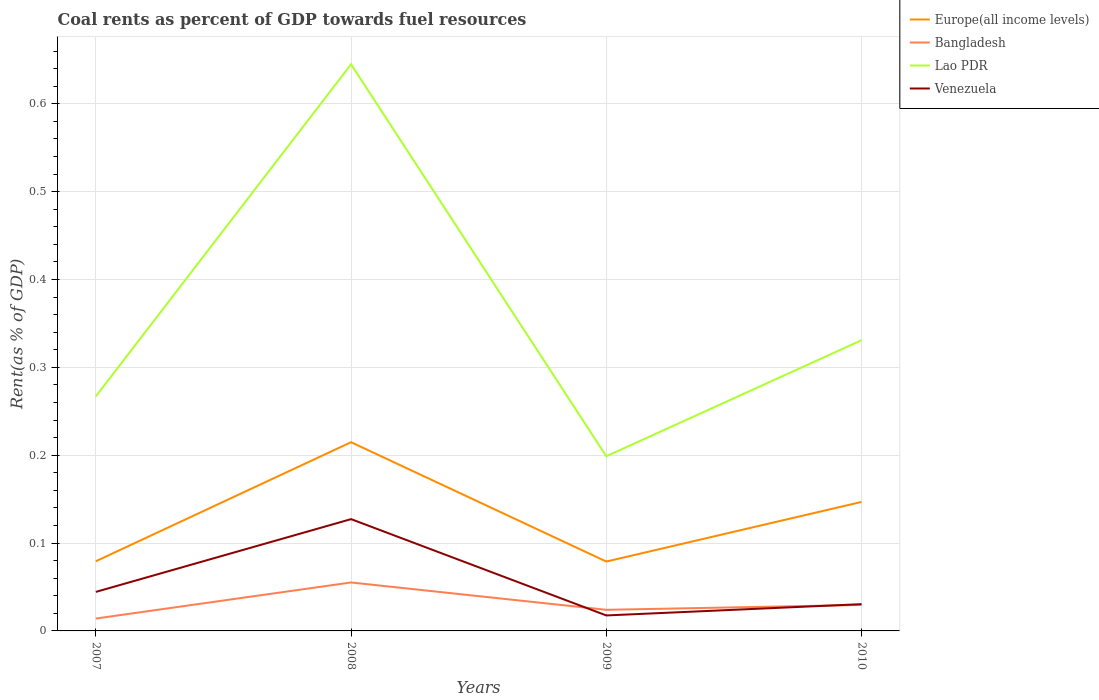How many different coloured lines are there?
Offer a terse response. 4. Does the line corresponding to Bangladesh intersect with the line corresponding to Lao PDR?
Ensure brevity in your answer.  No. Is the number of lines equal to the number of legend labels?
Give a very brief answer. Yes. Across all years, what is the maximum coal rent in Lao PDR?
Keep it short and to the point. 0.2. In which year was the coal rent in Bangladesh maximum?
Ensure brevity in your answer.  2007. What is the total coal rent in Europe(all income levels) in the graph?
Give a very brief answer. 0.07. What is the difference between the highest and the second highest coal rent in Venezuela?
Offer a terse response. 0.11. Is the coal rent in Lao PDR strictly greater than the coal rent in Bangladesh over the years?
Your answer should be compact. No. How many lines are there?
Make the answer very short. 4. What is the difference between two consecutive major ticks on the Y-axis?
Keep it short and to the point. 0.1. Are the values on the major ticks of Y-axis written in scientific E-notation?
Keep it short and to the point. No. Does the graph contain any zero values?
Give a very brief answer. No. What is the title of the graph?
Ensure brevity in your answer.  Coal rents as percent of GDP towards fuel resources. Does "OECD members" appear as one of the legend labels in the graph?
Your response must be concise. No. What is the label or title of the X-axis?
Keep it short and to the point. Years. What is the label or title of the Y-axis?
Provide a succinct answer. Rent(as % of GDP). What is the Rent(as % of GDP) of Europe(all income levels) in 2007?
Make the answer very short. 0.08. What is the Rent(as % of GDP) in Bangladesh in 2007?
Your answer should be compact. 0.01. What is the Rent(as % of GDP) of Lao PDR in 2007?
Your answer should be compact. 0.27. What is the Rent(as % of GDP) of Venezuela in 2007?
Your response must be concise. 0.04. What is the Rent(as % of GDP) in Europe(all income levels) in 2008?
Your response must be concise. 0.21. What is the Rent(as % of GDP) in Bangladesh in 2008?
Ensure brevity in your answer.  0.06. What is the Rent(as % of GDP) in Lao PDR in 2008?
Your answer should be compact. 0.65. What is the Rent(as % of GDP) in Venezuela in 2008?
Make the answer very short. 0.13. What is the Rent(as % of GDP) in Europe(all income levels) in 2009?
Ensure brevity in your answer.  0.08. What is the Rent(as % of GDP) of Bangladesh in 2009?
Keep it short and to the point. 0.02. What is the Rent(as % of GDP) in Lao PDR in 2009?
Keep it short and to the point. 0.2. What is the Rent(as % of GDP) of Venezuela in 2009?
Provide a short and direct response. 0.02. What is the Rent(as % of GDP) of Europe(all income levels) in 2010?
Your response must be concise. 0.15. What is the Rent(as % of GDP) in Bangladesh in 2010?
Your answer should be very brief. 0.03. What is the Rent(as % of GDP) in Lao PDR in 2010?
Your answer should be very brief. 0.33. What is the Rent(as % of GDP) of Venezuela in 2010?
Your response must be concise. 0.03. Across all years, what is the maximum Rent(as % of GDP) of Europe(all income levels)?
Offer a terse response. 0.21. Across all years, what is the maximum Rent(as % of GDP) of Bangladesh?
Provide a short and direct response. 0.06. Across all years, what is the maximum Rent(as % of GDP) in Lao PDR?
Offer a terse response. 0.65. Across all years, what is the maximum Rent(as % of GDP) in Venezuela?
Your answer should be very brief. 0.13. Across all years, what is the minimum Rent(as % of GDP) in Europe(all income levels)?
Keep it short and to the point. 0.08. Across all years, what is the minimum Rent(as % of GDP) of Bangladesh?
Provide a short and direct response. 0.01. Across all years, what is the minimum Rent(as % of GDP) of Lao PDR?
Provide a succinct answer. 0.2. Across all years, what is the minimum Rent(as % of GDP) of Venezuela?
Make the answer very short. 0.02. What is the total Rent(as % of GDP) of Europe(all income levels) in the graph?
Make the answer very short. 0.52. What is the total Rent(as % of GDP) in Bangladesh in the graph?
Your answer should be very brief. 0.12. What is the total Rent(as % of GDP) of Lao PDR in the graph?
Provide a succinct answer. 1.44. What is the total Rent(as % of GDP) of Venezuela in the graph?
Offer a terse response. 0.22. What is the difference between the Rent(as % of GDP) in Europe(all income levels) in 2007 and that in 2008?
Provide a succinct answer. -0.14. What is the difference between the Rent(as % of GDP) in Bangladesh in 2007 and that in 2008?
Your answer should be compact. -0.04. What is the difference between the Rent(as % of GDP) of Lao PDR in 2007 and that in 2008?
Keep it short and to the point. -0.38. What is the difference between the Rent(as % of GDP) of Venezuela in 2007 and that in 2008?
Provide a short and direct response. -0.08. What is the difference between the Rent(as % of GDP) of Europe(all income levels) in 2007 and that in 2009?
Provide a succinct answer. 0. What is the difference between the Rent(as % of GDP) of Bangladesh in 2007 and that in 2009?
Provide a succinct answer. -0.01. What is the difference between the Rent(as % of GDP) in Lao PDR in 2007 and that in 2009?
Make the answer very short. 0.07. What is the difference between the Rent(as % of GDP) of Venezuela in 2007 and that in 2009?
Keep it short and to the point. 0.03. What is the difference between the Rent(as % of GDP) in Europe(all income levels) in 2007 and that in 2010?
Keep it short and to the point. -0.07. What is the difference between the Rent(as % of GDP) in Bangladesh in 2007 and that in 2010?
Your answer should be very brief. -0.02. What is the difference between the Rent(as % of GDP) in Lao PDR in 2007 and that in 2010?
Provide a short and direct response. -0.06. What is the difference between the Rent(as % of GDP) in Venezuela in 2007 and that in 2010?
Provide a succinct answer. 0.01. What is the difference between the Rent(as % of GDP) in Europe(all income levels) in 2008 and that in 2009?
Keep it short and to the point. 0.14. What is the difference between the Rent(as % of GDP) of Bangladesh in 2008 and that in 2009?
Make the answer very short. 0.03. What is the difference between the Rent(as % of GDP) in Lao PDR in 2008 and that in 2009?
Provide a short and direct response. 0.45. What is the difference between the Rent(as % of GDP) in Venezuela in 2008 and that in 2009?
Give a very brief answer. 0.11. What is the difference between the Rent(as % of GDP) in Europe(all income levels) in 2008 and that in 2010?
Provide a short and direct response. 0.07. What is the difference between the Rent(as % of GDP) of Bangladesh in 2008 and that in 2010?
Keep it short and to the point. 0.03. What is the difference between the Rent(as % of GDP) of Lao PDR in 2008 and that in 2010?
Offer a very short reply. 0.31. What is the difference between the Rent(as % of GDP) of Venezuela in 2008 and that in 2010?
Your answer should be compact. 0.1. What is the difference between the Rent(as % of GDP) in Europe(all income levels) in 2009 and that in 2010?
Offer a very short reply. -0.07. What is the difference between the Rent(as % of GDP) in Bangladesh in 2009 and that in 2010?
Keep it short and to the point. -0.01. What is the difference between the Rent(as % of GDP) of Lao PDR in 2009 and that in 2010?
Give a very brief answer. -0.13. What is the difference between the Rent(as % of GDP) in Venezuela in 2009 and that in 2010?
Provide a short and direct response. -0.01. What is the difference between the Rent(as % of GDP) in Europe(all income levels) in 2007 and the Rent(as % of GDP) in Bangladesh in 2008?
Make the answer very short. 0.02. What is the difference between the Rent(as % of GDP) in Europe(all income levels) in 2007 and the Rent(as % of GDP) in Lao PDR in 2008?
Offer a terse response. -0.57. What is the difference between the Rent(as % of GDP) in Europe(all income levels) in 2007 and the Rent(as % of GDP) in Venezuela in 2008?
Give a very brief answer. -0.05. What is the difference between the Rent(as % of GDP) in Bangladesh in 2007 and the Rent(as % of GDP) in Lao PDR in 2008?
Make the answer very short. -0.63. What is the difference between the Rent(as % of GDP) of Bangladesh in 2007 and the Rent(as % of GDP) of Venezuela in 2008?
Provide a short and direct response. -0.11. What is the difference between the Rent(as % of GDP) in Lao PDR in 2007 and the Rent(as % of GDP) in Venezuela in 2008?
Make the answer very short. 0.14. What is the difference between the Rent(as % of GDP) in Europe(all income levels) in 2007 and the Rent(as % of GDP) in Bangladesh in 2009?
Ensure brevity in your answer.  0.06. What is the difference between the Rent(as % of GDP) in Europe(all income levels) in 2007 and the Rent(as % of GDP) in Lao PDR in 2009?
Keep it short and to the point. -0.12. What is the difference between the Rent(as % of GDP) of Europe(all income levels) in 2007 and the Rent(as % of GDP) of Venezuela in 2009?
Keep it short and to the point. 0.06. What is the difference between the Rent(as % of GDP) in Bangladesh in 2007 and the Rent(as % of GDP) in Lao PDR in 2009?
Offer a very short reply. -0.18. What is the difference between the Rent(as % of GDP) in Bangladesh in 2007 and the Rent(as % of GDP) in Venezuela in 2009?
Keep it short and to the point. -0. What is the difference between the Rent(as % of GDP) in Lao PDR in 2007 and the Rent(as % of GDP) in Venezuela in 2009?
Your response must be concise. 0.25. What is the difference between the Rent(as % of GDP) of Europe(all income levels) in 2007 and the Rent(as % of GDP) of Bangladesh in 2010?
Give a very brief answer. 0.05. What is the difference between the Rent(as % of GDP) of Europe(all income levels) in 2007 and the Rent(as % of GDP) of Lao PDR in 2010?
Ensure brevity in your answer.  -0.25. What is the difference between the Rent(as % of GDP) in Europe(all income levels) in 2007 and the Rent(as % of GDP) in Venezuela in 2010?
Your response must be concise. 0.05. What is the difference between the Rent(as % of GDP) in Bangladesh in 2007 and the Rent(as % of GDP) in Lao PDR in 2010?
Keep it short and to the point. -0.32. What is the difference between the Rent(as % of GDP) in Bangladesh in 2007 and the Rent(as % of GDP) in Venezuela in 2010?
Keep it short and to the point. -0.02. What is the difference between the Rent(as % of GDP) of Lao PDR in 2007 and the Rent(as % of GDP) of Venezuela in 2010?
Give a very brief answer. 0.24. What is the difference between the Rent(as % of GDP) of Europe(all income levels) in 2008 and the Rent(as % of GDP) of Bangladesh in 2009?
Your answer should be compact. 0.19. What is the difference between the Rent(as % of GDP) in Europe(all income levels) in 2008 and the Rent(as % of GDP) in Lao PDR in 2009?
Your answer should be very brief. 0.02. What is the difference between the Rent(as % of GDP) of Europe(all income levels) in 2008 and the Rent(as % of GDP) of Venezuela in 2009?
Offer a terse response. 0.2. What is the difference between the Rent(as % of GDP) of Bangladesh in 2008 and the Rent(as % of GDP) of Lao PDR in 2009?
Provide a short and direct response. -0.14. What is the difference between the Rent(as % of GDP) of Bangladesh in 2008 and the Rent(as % of GDP) of Venezuela in 2009?
Your answer should be very brief. 0.04. What is the difference between the Rent(as % of GDP) of Lao PDR in 2008 and the Rent(as % of GDP) of Venezuela in 2009?
Ensure brevity in your answer.  0.63. What is the difference between the Rent(as % of GDP) of Europe(all income levels) in 2008 and the Rent(as % of GDP) of Bangladesh in 2010?
Keep it short and to the point. 0.19. What is the difference between the Rent(as % of GDP) in Europe(all income levels) in 2008 and the Rent(as % of GDP) in Lao PDR in 2010?
Your answer should be very brief. -0.12. What is the difference between the Rent(as % of GDP) in Europe(all income levels) in 2008 and the Rent(as % of GDP) in Venezuela in 2010?
Provide a short and direct response. 0.18. What is the difference between the Rent(as % of GDP) of Bangladesh in 2008 and the Rent(as % of GDP) of Lao PDR in 2010?
Keep it short and to the point. -0.28. What is the difference between the Rent(as % of GDP) in Bangladesh in 2008 and the Rent(as % of GDP) in Venezuela in 2010?
Offer a terse response. 0.02. What is the difference between the Rent(as % of GDP) in Lao PDR in 2008 and the Rent(as % of GDP) in Venezuela in 2010?
Your answer should be very brief. 0.61. What is the difference between the Rent(as % of GDP) in Europe(all income levels) in 2009 and the Rent(as % of GDP) in Bangladesh in 2010?
Provide a succinct answer. 0.05. What is the difference between the Rent(as % of GDP) of Europe(all income levels) in 2009 and the Rent(as % of GDP) of Lao PDR in 2010?
Ensure brevity in your answer.  -0.25. What is the difference between the Rent(as % of GDP) in Europe(all income levels) in 2009 and the Rent(as % of GDP) in Venezuela in 2010?
Offer a very short reply. 0.05. What is the difference between the Rent(as % of GDP) in Bangladesh in 2009 and the Rent(as % of GDP) in Lao PDR in 2010?
Provide a succinct answer. -0.31. What is the difference between the Rent(as % of GDP) in Bangladesh in 2009 and the Rent(as % of GDP) in Venezuela in 2010?
Provide a succinct answer. -0.01. What is the difference between the Rent(as % of GDP) of Lao PDR in 2009 and the Rent(as % of GDP) of Venezuela in 2010?
Offer a very short reply. 0.17. What is the average Rent(as % of GDP) of Europe(all income levels) per year?
Provide a short and direct response. 0.13. What is the average Rent(as % of GDP) of Bangladesh per year?
Provide a short and direct response. 0.03. What is the average Rent(as % of GDP) in Lao PDR per year?
Provide a succinct answer. 0.36. What is the average Rent(as % of GDP) of Venezuela per year?
Your answer should be very brief. 0.05. In the year 2007, what is the difference between the Rent(as % of GDP) of Europe(all income levels) and Rent(as % of GDP) of Bangladesh?
Your response must be concise. 0.07. In the year 2007, what is the difference between the Rent(as % of GDP) of Europe(all income levels) and Rent(as % of GDP) of Lao PDR?
Offer a very short reply. -0.19. In the year 2007, what is the difference between the Rent(as % of GDP) in Europe(all income levels) and Rent(as % of GDP) in Venezuela?
Offer a terse response. 0.03. In the year 2007, what is the difference between the Rent(as % of GDP) in Bangladesh and Rent(as % of GDP) in Lao PDR?
Ensure brevity in your answer.  -0.25. In the year 2007, what is the difference between the Rent(as % of GDP) in Bangladesh and Rent(as % of GDP) in Venezuela?
Ensure brevity in your answer.  -0.03. In the year 2007, what is the difference between the Rent(as % of GDP) in Lao PDR and Rent(as % of GDP) in Venezuela?
Your answer should be compact. 0.22. In the year 2008, what is the difference between the Rent(as % of GDP) in Europe(all income levels) and Rent(as % of GDP) in Bangladesh?
Provide a succinct answer. 0.16. In the year 2008, what is the difference between the Rent(as % of GDP) in Europe(all income levels) and Rent(as % of GDP) in Lao PDR?
Your answer should be compact. -0.43. In the year 2008, what is the difference between the Rent(as % of GDP) in Europe(all income levels) and Rent(as % of GDP) in Venezuela?
Ensure brevity in your answer.  0.09. In the year 2008, what is the difference between the Rent(as % of GDP) in Bangladesh and Rent(as % of GDP) in Lao PDR?
Provide a succinct answer. -0.59. In the year 2008, what is the difference between the Rent(as % of GDP) in Bangladesh and Rent(as % of GDP) in Venezuela?
Your answer should be very brief. -0.07. In the year 2008, what is the difference between the Rent(as % of GDP) in Lao PDR and Rent(as % of GDP) in Venezuela?
Give a very brief answer. 0.52. In the year 2009, what is the difference between the Rent(as % of GDP) in Europe(all income levels) and Rent(as % of GDP) in Bangladesh?
Your answer should be compact. 0.05. In the year 2009, what is the difference between the Rent(as % of GDP) in Europe(all income levels) and Rent(as % of GDP) in Lao PDR?
Offer a terse response. -0.12. In the year 2009, what is the difference between the Rent(as % of GDP) of Europe(all income levels) and Rent(as % of GDP) of Venezuela?
Offer a very short reply. 0.06. In the year 2009, what is the difference between the Rent(as % of GDP) in Bangladesh and Rent(as % of GDP) in Lao PDR?
Give a very brief answer. -0.17. In the year 2009, what is the difference between the Rent(as % of GDP) of Bangladesh and Rent(as % of GDP) of Venezuela?
Provide a short and direct response. 0.01. In the year 2009, what is the difference between the Rent(as % of GDP) of Lao PDR and Rent(as % of GDP) of Venezuela?
Your answer should be very brief. 0.18. In the year 2010, what is the difference between the Rent(as % of GDP) in Europe(all income levels) and Rent(as % of GDP) in Bangladesh?
Your answer should be very brief. 0.12. In the year 2010, what is the difference between the Rent(as % of GDP) in Europe(all income levels) and Rent(as % of GDP) in Lao PDR?
Offer a very short reply. -0.18. In the year 2010, what is the difference between the Rent(as % of GDP) in Europe(all income levels) and Rent(as % of GDP) in Venezuela?
Your answer should be very brief. 0.12. In the year 2010, what is the difference between the Rent(as % of GDP) in Bangladesh and Rent(as % of GDP) in Lao PDR?
Make the answer very short. -0.3. In the year 2010, what is the difference between the Rent(as % of GDP) of Bangladesh and Rent(as % of GDP) of Venezuela?
Your response must be concise. -0. In the year 2010, what is the difference between the Rent(as % of GDP) in Lao PDR and Rent(as % of GDP) in Venezuela?
Your answer should be compact. 0.3. What is the ratio of the Rent(as % of GDP) of Europe(all income levels) in 2007 to that in 2008?
Give a very brief answer. 0.37. What is the ratio of the Rent(as % of GDP) of Bangladesh in 2007 to that in 2008?
Keep it short and to the point. 0.26. What is the ratio of the Rent(as % of GDP) in Lao PDR in 2007 to that in 2008?
Your answer should be very brief. 0.41. What is the ratio of the Rent(as % of GDP) in Venezuela in 2007 to that in 2008?
Your answer should be compact. 0.35. What is the ratio of the Rent(as % of GDP) in Europe(all income levels) in 2007 to that in 2009?
Ensure brevity in your answer.  1. What is the ratio of the Rent(as % of GDP) in Bangladesh in 2007 to that in 2009?
Your response must be concise. 0.59. What is the ratio of the Rent(as % of GDP) in Lao PDR in 2007 to that in 2009?
Your answer should be compact. 1.34. What is the ratio of the Rent(as % of GDP) in Venezuela in 2007 to that in 2009?
Provide a succinct answer. 2.52. What is the ratio of the Rent(as % of GDP) of Europe(all income levels) in 2007 to that in 2010?
Offer a terse response. 0.54. What is the ratio of the Rent(as % of GDP) in Bangladesh in 2007 to that in 2010?
Provide a short and direct response. 0.48. What is the ratio of the Rent(as % of GDP) in Lao PDR in 2007 to that in 2010?
Give a very brief answer. 0.81. What is the ratio of the Rent(as % of GDP) of Venezuela in 2007 to that in 2010?
Your answer should be compact. 1.46. What is the ratio of the Rent(as % of GDP) of Europe(all income levels) in 2008 to that in 2009?
Provide a succinct answer. 2.72. What is the ratio of the Rent(as % of GDP) in Bangladesh in 2008 to that in 2009?
Give a very brief answer. 2.3. What is the ratio of the Rent(as % of GDP) in Lao PDR in 2008 to that in 2009?
Make the answer very short. 3.24. What is the ratio of the Rent(as % of GDP) of Venezuela in 2008 to that in 2009?
Provide a short and direct response. 7.22. What is the ratio of the Rent(as % of GDP) of Europe(all income levels) in 2008 to that in 2010?
Provide a short and direct response. 1.46. What is the ratio of the Rent(as % of GDP) in Bangladesh in 2008 to that in 2010?
Make the answer very short. 1.86. What is the ratio of the Rent(as % of GDP) in Lao PDR in 2008 to that in 2010?
Provide a succinct answer. 1.95. What is the ratio of the Rent(as % of GDP) in Venezuela in 2008 to that in 2010?
Your answer should be compact. 4.18. What is the ratio of the Rent(as % of GDP) in Europe(all income levels) in 2009 to that in 2010?
Your response must be concise. 0.54. What is the ratio of the Rent(as % of GDP) of Bangladesh in 2009 to that in 2010?
Ensure brevity in your answer.  0.81. What is the ratio of the Rent(as % of GDP) of Lao PDR in 2009 to that in 2010?
Offer a very short reply. 0.6. What is the ratio of the Rent(as % of GDP) in Venezuela in 2009 to that in 2010?
Give a very brief answer. 0.58. What is the difference between the highest and the second highest Rent(as % of GDP) in Europe(all income levels)?
Your response must be concise. 0.07. What is the difference between the highest and the second highest Rent(as % of GDP) in Bangladesh?
Give a very brief answer. 0.03. What is the difference between the highest and the second highest Rent(as % of GDP) in Lao PDR?
Your answer should be compact. 0.31. What is the difference between the highest and the second highest Rent(as % of GDP) of Venezuela?
Your answer should be compact. 0.08. What is the difference between the highest and the lowest Rent(as % of GDP) of Europe(all income levels)?
Ensure brevity in your answer.  0.14. What is the difference between the highest and the lowest Rent(as % of GDP) of Bangladesh?
Provide a succinct answer. 0.04. What is the difference between the highest and the lowest Rent(as % of GDP) in Lao PDR?
Provide a short and direct response. 0.45. What is the difference between the highest and the lowest Rent(as % of GDP) in Venezuela?
Your answer should be very brief. 0.11. 